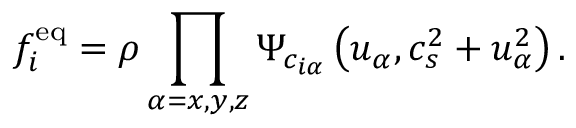Convert formula to latex. <formula><loc_0><loc_0><loc_500><loc_500>f _ { i } ^ { e q } = \rho \prod _ { \alpha = x , y , z } \Psi _ { c _ { i \alpha } } \left ( u _ { \alpha } , c _ { s } ^ { 2 } + u _ { \alpha } ^ { 2 } \right ) .</formula> 